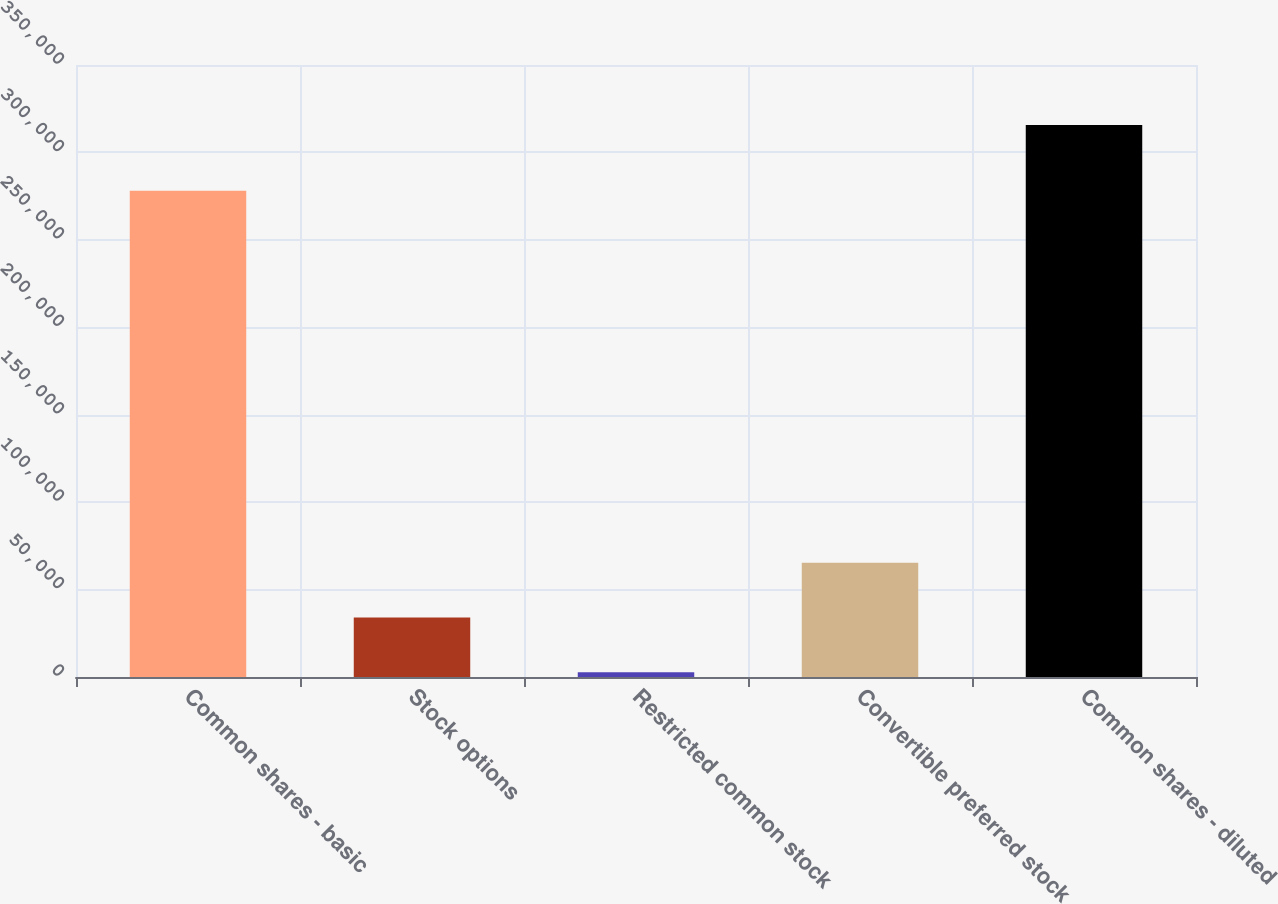Convert chart to OTSL. <chart><loc_0><loc_0><loc_500><loc_500><bar_chart><fcel>Common shares - basic<fcel>Stock options<fcel>Restricted common stock<fcel>Convertible preferred stock<fcel>Common shares - diluted<nl><fcel>278100<fcel>34065.1<fcel>2776<fcel>65354.2<fcel>315667<nl></chart> 